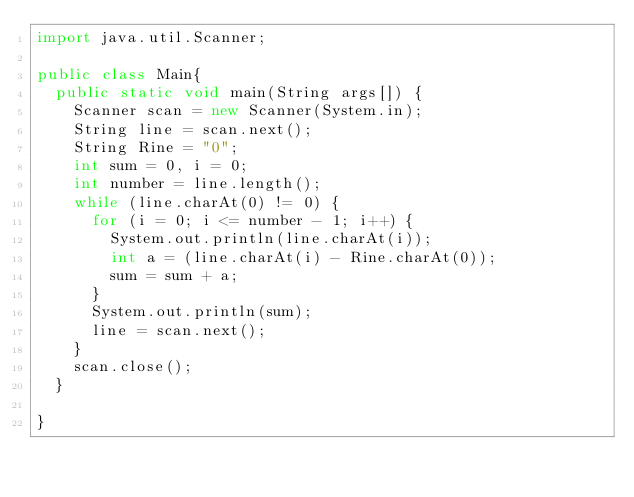<code> <loc_0><loc_0><loc_500><loc_500><_Java_>import java.util.Scanner;

public class Main{
	public static void main(String args[]) {
		Scanner scan = new Scanner(System.in);
		String line = scan.next();
		String Rine = "0";
		int sum = 0, i = 0;
		int number = line.length();
		while (line.charAt(0) != 0) {
			for (i = 0; i <= number - 1; i++) {
				System.out.println(line.charAt(i));
				int a = (line.charAt(i) - Rine.charAt(0));
				sum = sum + a;
			}
			System.out.println(sum);
			line = scan.next();
		}
		scan.close();
	}

}</code> 